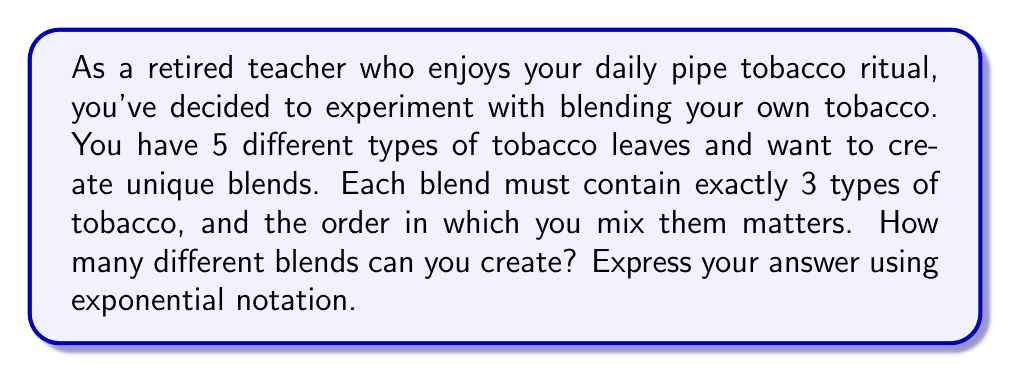Show me your answer to this math problem. Let's approach this step-by-step:

1) This is a permutation problem, as the order matters in mixing the tobacco.

2) We are selecting 3 types of tobacco out of 5 available types, where repetition is not allowed (we don't use the same type of tobacco more than once in a blend).

3) For the first selection, we have 5 choices.

4) For the second selection, we have 4 choices (as we can't repeat the first type).

5) For the third selection, we have 3 choices.

6) The total number of possible blends is the product of these choices:

   $5 \times 4 \times 3 = 60$

7) We can express this using factorials:

   $$\frac{5!}{(5-3)!} = \frac{5!}{2!} = 60$$

8) To express this in exponential notation, we need to find a base and exponent that equal 60.

9) $60 = 2^2 \times 3 \times 5$

10) We can rewrite this as:

    $$60 = 2^2 \times 3^1 \times 5^1 = (2^2 \times 3 \times 5)^1$$

Therefore, the number of possible blends can be expressed as $(2^2 \times 3 \times 5)^1$ in exponential notation.
Answer: $(2^2 \times 3 \times 5)^1$ 